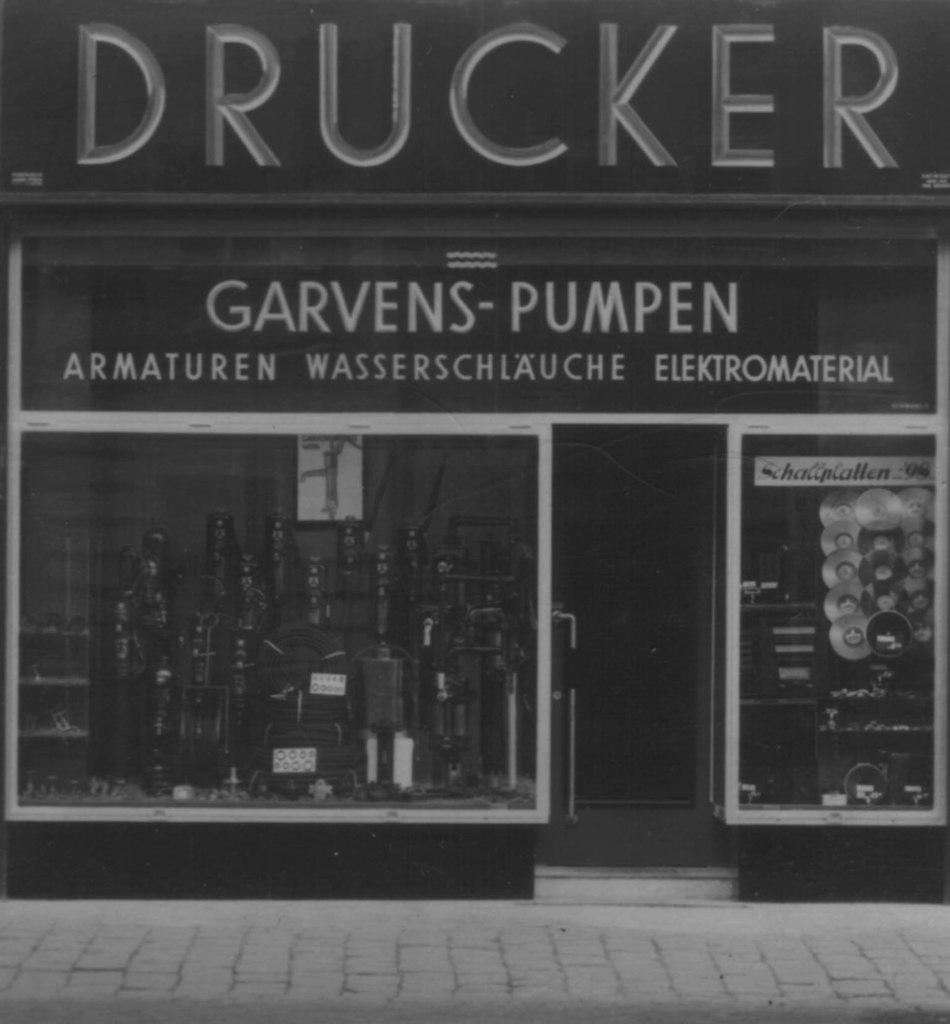What is the color scheme of the image? The image is black and white. What type of establishment can be seen in the image? There is a store in the image. What feature is present on the store that allows access? There is a door in the image. What can be found on the boards in the image? There are boards with text in the image. Can you hear the guitar playing in the background of the image? There is no guitar or sound present in the image, as it is a still, black and white photograph. 